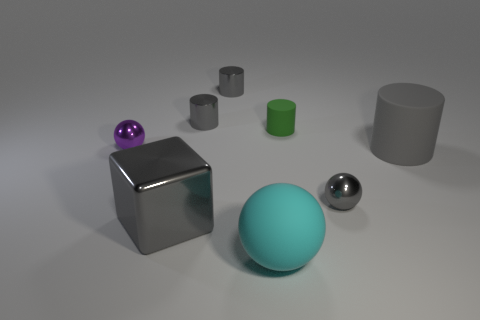Subtract all gray cylinders. How many were subtracted if there are1gray cylinders left? 2 Subtract all cyan cubes. How many gray cylinders are left? 3 Subtract all cyan cylinders. Subtract all blue balls. How many cylinders are left? 4 Add 1 big blue things. How many objects exist? 9 Subtract all spheres. How many objects are left? 5 Add 1 small red shiny balls. How many small red shiny balls exist? 1 Subtract 1 purple spheres. How many objects are left? 7 Subtract all matte blocks. Subtract all large matte cylinders. How many objects are left? 7 Add 6 large gray metal things. How many large gray metal things are left? 7 